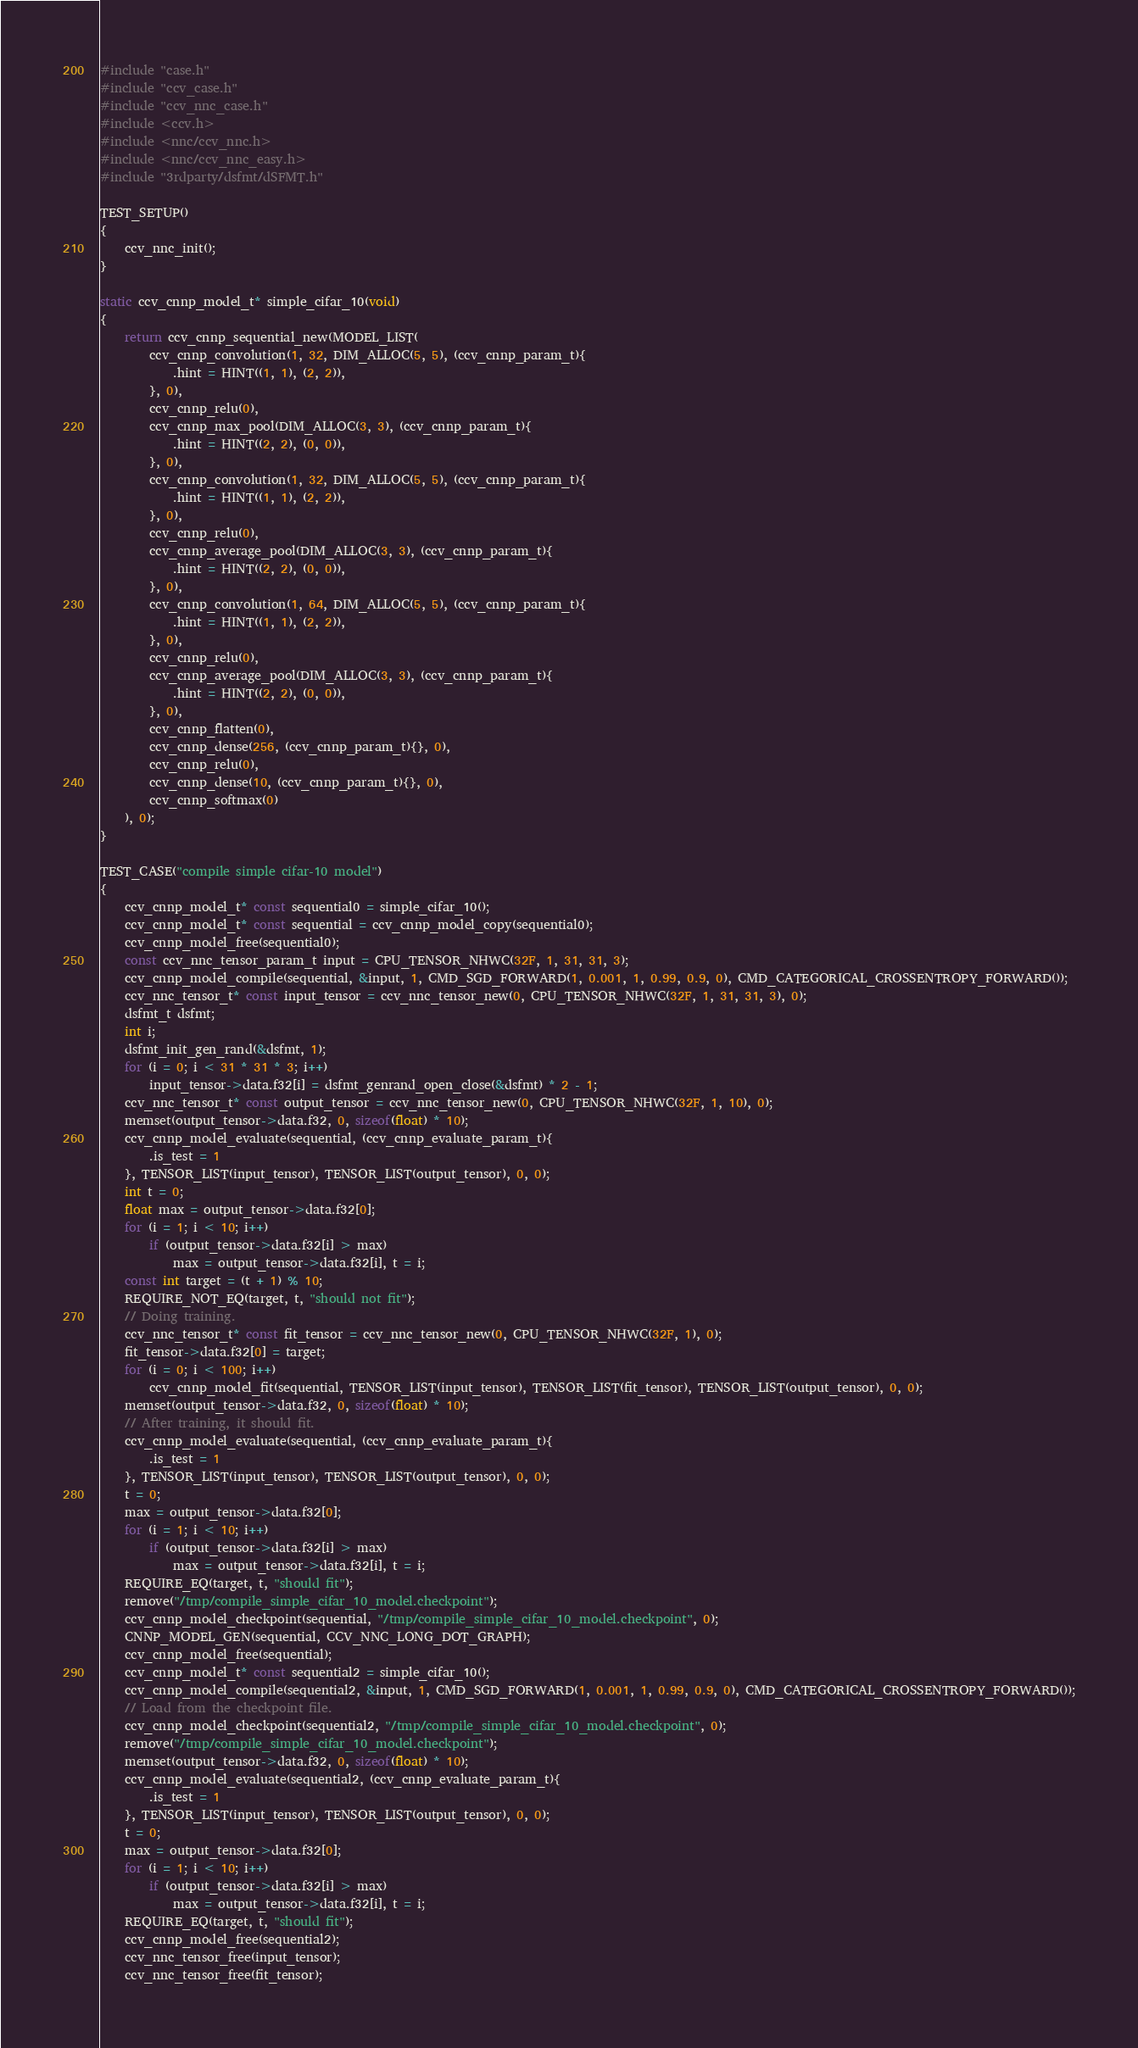Convert code to text. <code><loc_0><loc_0><loc_500><loc_500><_C_>#include "case.h"
#include "ccv_case.h"
#include "ccv_nnc_case.h"
#include <ccv.h>
#include <nnc/ccv_nnc.h>
#include <nnc/ccv_nnc_easy.h>
#include "3rdparty/dsfmt/dSFMT.h"

TEST_SETUP()
{
	ccv_nnc_init();
}

static ccv_cnnp_model_t* simple_cifar_10(void)
{
	return ccv_cnnp_sequential_new(MODEL_LIST(
		ccv_cnnp_convolution(1, 32, DIM_ALLOC(5, 5), (ccv_cnnp_param_t){
			.hint = HINT((1, 1), (2, 2)),
		}, 0),
		ccv_cnnp_relu(0),
		ccv_cnnp_max_pool(DIM_ALLOC(3, 3), (ccv_cnnp_param_t){
			.hint = HINT((2, 2), (0, 0)),
		}, 0),
		ccv_cnnp_convolution(1, 32, DIM_ALLOC(5, 5), (ccv_cnnp_param_t){
			.hint = HINT((1, 1), (2, 2)),
		}, 0),
		ccv_cnnp_relu(0),
		ccv_cnnp_average_pool(DIM_ALLOC(3, 3), (ccv_cnnp_param_t){
			.hint = HINT((2, 2), (0, 0)),
		}, 0),
		ccv_cnnp_convolution(1, 64, DIM_ALLOC(5, 5), (ccv_cnnp_param_t){
			.hint = HINT((1, 1), (2, 2)),
		}, 0),
		ccv_cnnp_relu(0),
		ccv_cnnp_average_pool(DIM_ALLOC(3, 3), (ccv_cnnp_param_t){
			.hint = HINT((2, 2), (0, 0)),
		}, 0),
		ccv_cnnp_flatten(0),
		ccv_cnnp_dense(256, (ccv_cnnp_param_t){}, 0),
		ccv_cnnp_relu(0),
		ccv_cnnp_dense(10, (ccv_cnnp_param_t){}, 0),
		ccv_cnnp_softmax(0)
	), 0);
}

TEST_CASE("compile simple cifar-10 model")
{
	ccv_cnnp_model_t* const sequential0 = simple_cifar_10();
	ccv_cnnp_model_t* const sequential = ccv_cnnp_model_copy(sequential0);
	ccv_cnnp_model_free(sequential0);
	const ccv_nnc_tensor_param_t input = CPU_TENSOR_NHWC(32F, 1, 31, 31, 3);
	ccv_cnnp_model_compile(sequential, &input, 1, CMD_SGD_FORWARD(1, 0.001, 1, 0.99, 0.9, 0), CMD_CATEGORICAL_CROSSENTROPY_FORWARD());
	ccv_nnc_tensor_t* const input_tensor = ccv_nnc_tensor_new(0, CPU_TENSOR_NHWC(32F, 1, 31, 31, 3), 0);
	dsfmt_t dsfmt;
	int i;
	dsfmt_init_gen_rand(&dsfmt, 1);
	for (i = 0; i < 31 * 31 * 3; i++)
		input_tensor->data.f32[i] = dsfmt_genrand_open_close(&dsfmt) * 2 - 1;
	ccv_nnc_tensor_t* const output_tensor = ccv_nnc_tensor_new(0, CPU_TENSOR_NHWC(32F, 1, 10), 0);
	memset(output_tensor->data.f32, 0, sizeof(float) * 10);
	ccv_cnnp_model_evaluate(sequential, (ccv_cnnp_evaluate_param_t){
		.is_test = 1
	}, TENSOR_LIST(input_tensor), TENSOR_LIST(output_tensor), 0, 0);
	int t = 0;
	float max = output_tensor->data.f32[0];
	for (i = 1; i < 10; i++)
		if (output_tensor->data.f32[i] > max)
			max = output_tensor->data.f32[i], t = i;
	const int target = (t + 1) % 10;
	REQUIRE_NOT_EQ(target, t, "should not fit");
	// Doing training.
	ccv_nnc_tensor_t* const fit_tensor = ccv_nnc_tensor_new(0, CPU_TENSOR_NHWC(32F, 1), 0);
	fit_tensor->data.f32[0] = target;
	for (i = 0; i < 100; i++)
		ccv_cnnp_model_fit(sequential, TENSOR_LIST(input_tensor), TENSOR_LIST(fit_tensor), TENSOR_LIST(output_tensor), 0, 0);
	memset(output_tensor->data.f32, 0, sizeof(float) * 10);
	// After training, it should fit.
	ccv_cnnp_model_evaluate(sequential, (ccv_cnnp_evaluate_param_t){
		.is_test = 1
	}, TENSOR_LIST(input_tensor), TENSOR_LIST(output_tensor), 0, 0);
	t = 0;
	max = output_tensor->data.f32[0];
	for (i = 1; i < 10; i++)
		if (output_tensor->data.f32[i] > max)
			max = output_tensor->data.f32[i], t = i;
	REQUIRE_EQ(target, t, "should fit");
	remove("/tmp/compile_simple_cifar_10_model.checkpoint");
	ccv_cnnp_model_checkpoint(sequential, "/tmp/compile_simple_cifar_10_model.checkpoint", 0);
	CNNP_MODEL_GEN(sequential, CCV_NNC_LONG_DOT_GRAPH);
	ccv_cnnp_model_free(sequential);
	ccv_cnnp_model_t* const sequential2 = simple_cifar_10();
	ccv_cnnp_model_compile(sequential2, &input, 1, CMD_SGD_FORWARD(1, 0.001, 1, 0.99, 0.9, 0), CMD_CATEGORICAL_CROSSENTROPY_FORWARD());
	// Load from the checkpoint file.
	ccv_cnnp_model_checkpoint(sequential2, "/tmp/compile_simple_cifar_10_model.checkpoint", 0);
	remove("/tmp/compile_simple_cifar_10_model.checkpoint");
	memset(output_tensor->data.f32, 0, sizeof(float) * 10);
	ccv_cnnp_model_evaluate(sequential2, (ccv_cnnp_evaluate_param_t){
		.is_test = 1
	}, TENSOR_LIST(input_tensor), TENSOR_LIST(output_tensor), 0, 0);
	t = 0;
	max = output_tensor->data.f32[0];
	for (i = 1; i < 10; i++)
		if (output_tensor->data.f32[i] > max)
			max = output_tensor->data.f32[i], t = i;
	REQUIRE_EQ(target, t, "should fit");
	ccv_cnnp_model_free(sequential2);
	ccv_nnc_tensor_free(input_tensor);
	ccv_nnc_tensor_free(fit_tensor);</code> 